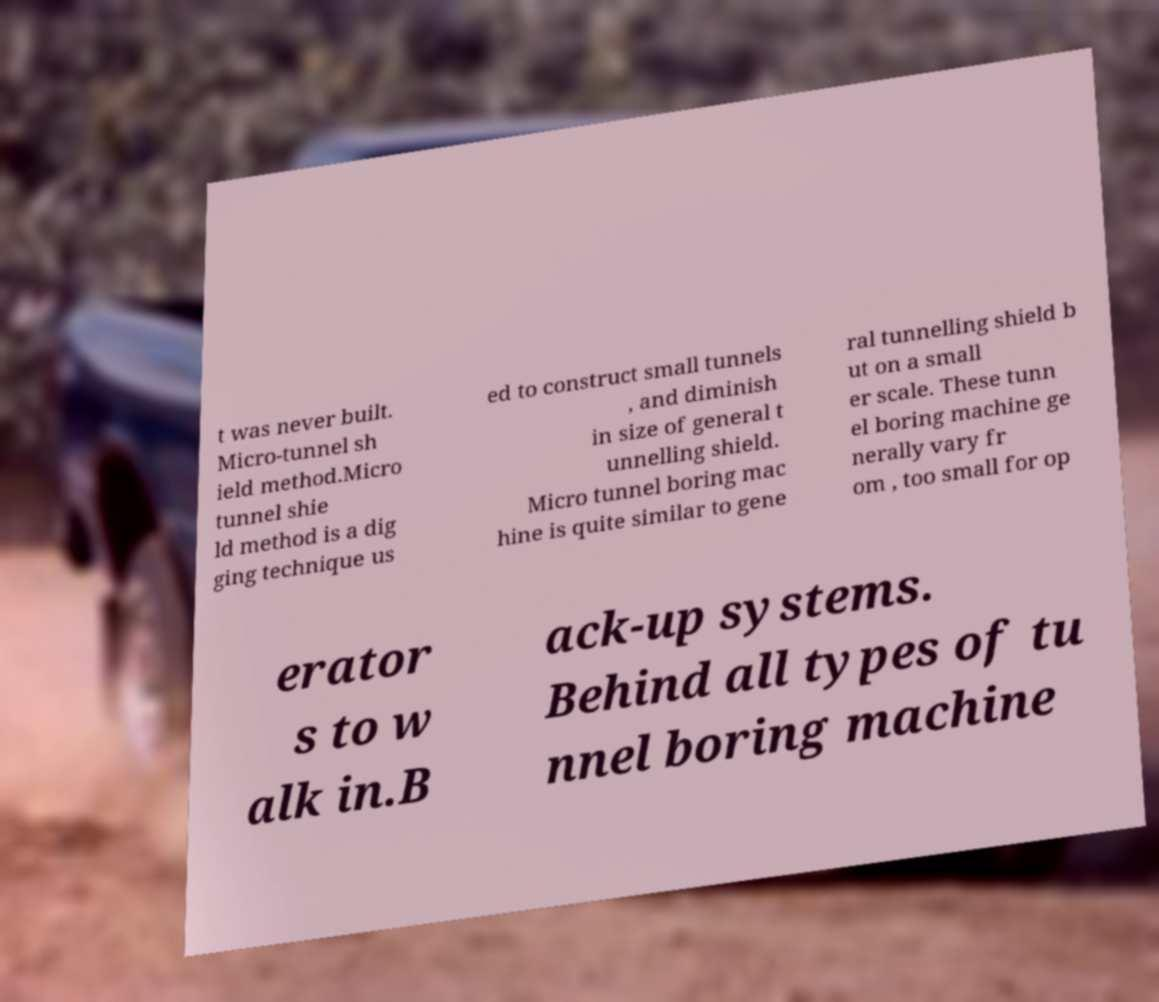There's text embedded in this image that I need extracted. Can you transcribe it verbatim? t was never built. Micro-tunnel sh ield method.Micro tunnel shie ld method is a dig ging technique us ed to construct small tunnels , and diminish in size of general t unnelling shield. Micro tunnel boring mac hine is quite similar to gene ral tunnelling shield b ut on a small er scale. These tunn el boring machine ge nerally vary fr om , too small for op erator s to w alk in.B ack-up systems. Behind all types of tu nnel boring machine 